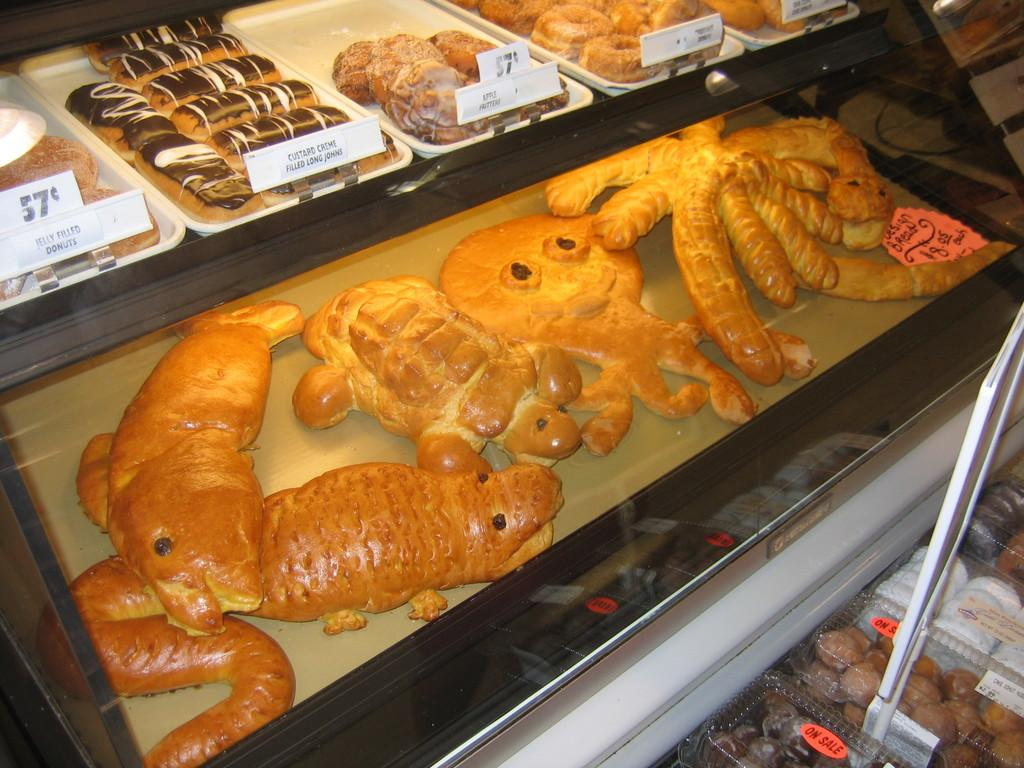What can be found in the trays in the image? There are food items in the trays in the image. How can one identify which food items belong to whom? There are name plates in front of the food items. What type of thunder can be heard in the image? There is no thunder present in the image, as it is a still image and not an audio recording. 